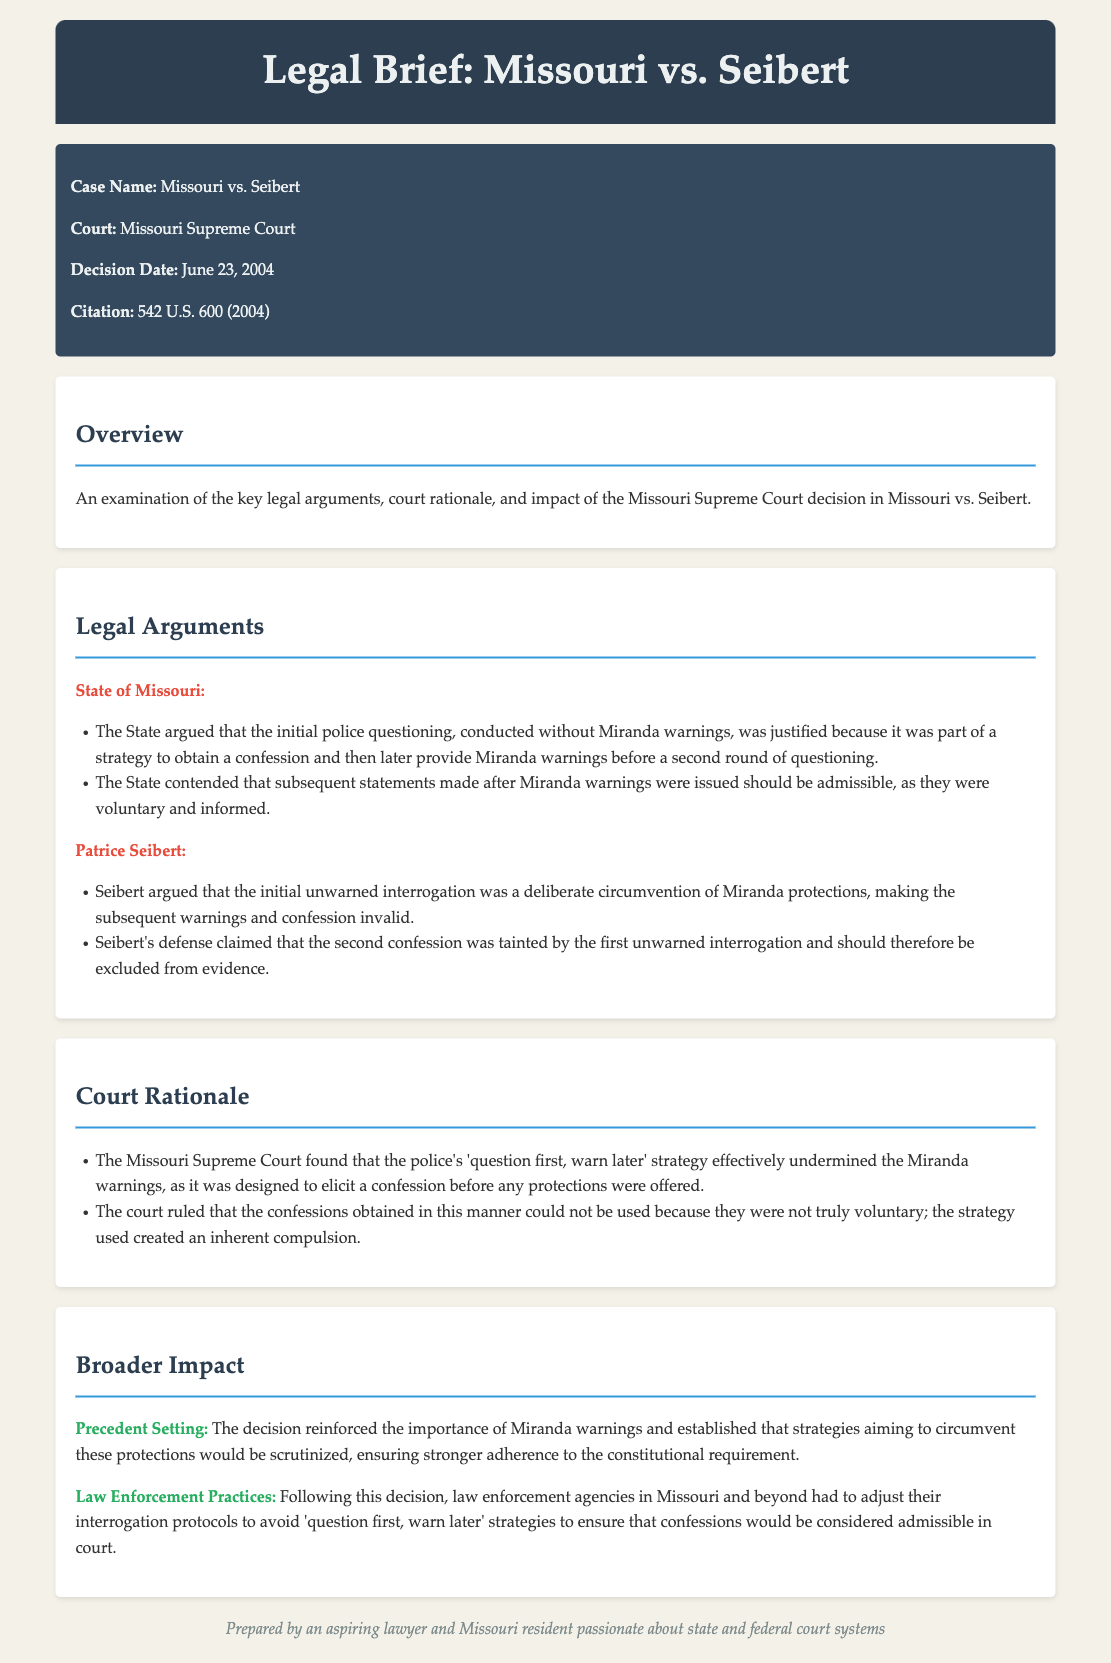what is the case name? The case name is identified at the beginning of the document and is specific to this legal brief.
Answer: Missouri vs. Seibert when was the decision made? The decision date is clearly stated in the case details section of the document.
Answer: June 23, 2004 what was the citation for the case? The citation provides a legal reference for the case and is included in the case details.
Answer: 542 U.S. 600 (2004) what legal strategy did the State of Missouri argue was justified? This question pertains to the arguments made by the State and is outlined in the legal arguments section.
Answer: 'Question first, warn later' strategy what did Patrice Seibert argue about the initial interrogation? This question requires understanding Seibert's position from the legal arguments presented.
Answer: Circumvention of Miranda protections what was the court's conclusion about the confessions obtained? The court's rationale is summarized in the rationale section and addresses the validity of the confessions.
Answer: Not truly voluntary how did the decision impact law enforcement practices? This question is aimed at understanding the broader implications of the court's decision noted in the impact section.
Answer: Adjust interrogation protocols what does the term "precedent setting" refer to in this case? The phrase "precedent setting" appears in the impact section and relates to the implications of the legal decision.
Answer: Reinforced importance of Miranda warnings what was the Missouri Supreme Court's finding on police strategy? This question seeks to summarize the court's view on the police's tactics mentioned in the court rationale.
Answer: Undermined the Miranda warnings 